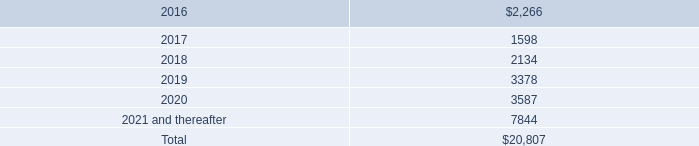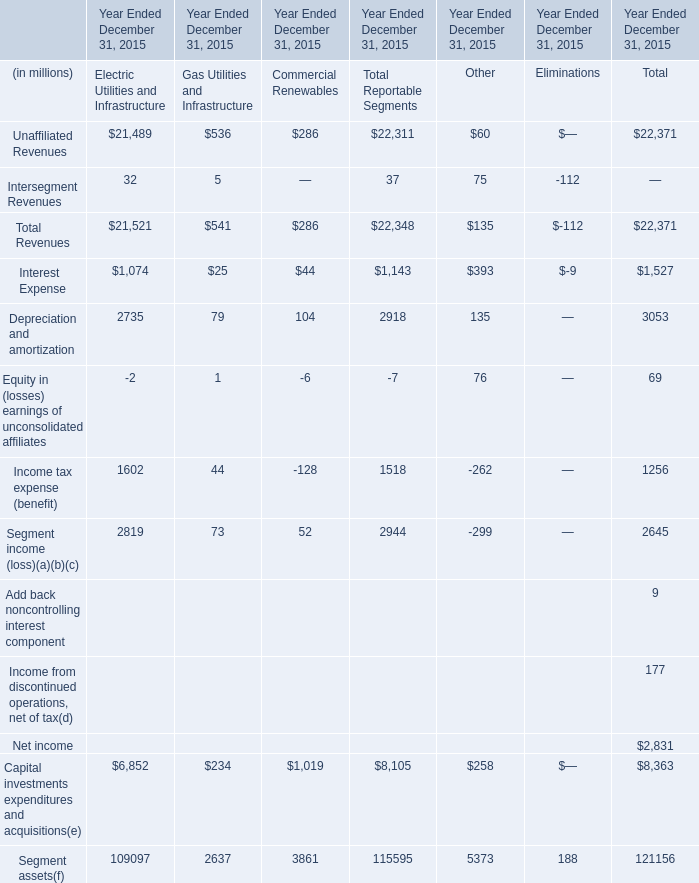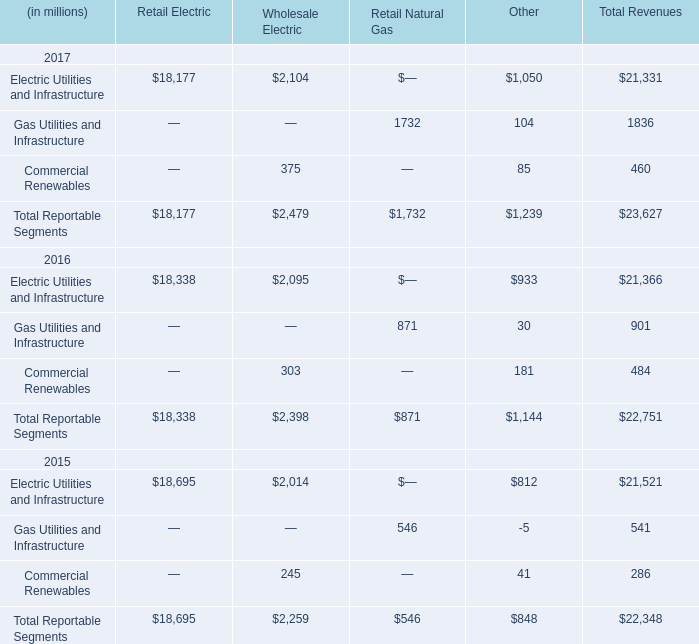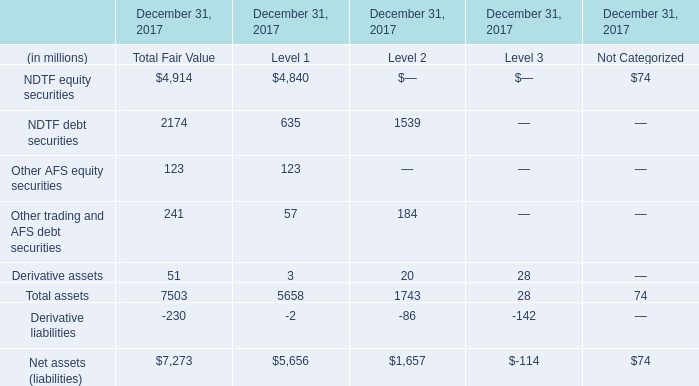In which year is Commercial Renewables in Total Revenues positive? 
Answer: 2015; 2016; 2017. 